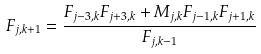Convert formula to latex. <formula><loc_0><loc_0><loc_500><loc_500>F _ { j , k + 1 } = \frac { F _ { j - 3 , k } F _ { j + 3 , k } + M _ { j , k } F _ { j - 1 , k } F _ { j + 1 , k } } { F _ { j , k - 1 } }</formula> 